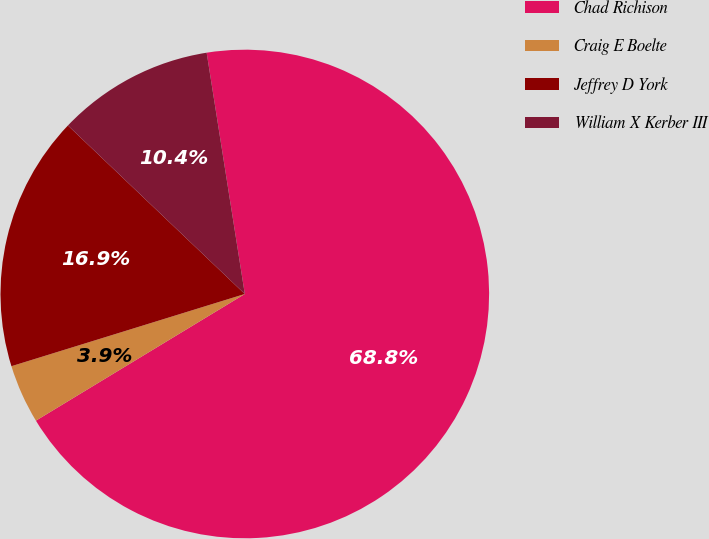<chart> <loc_0><loc_0><loc_500><loc_500><pie_chart><fcel>Chad Richison<fcel>Craig E Boelte<fcel>Jeffrey D York<fcel>William X Kerber III<nl><fcel>68.82%<fcel>3.9%<fcel>16.89%<fcel>10.39%<nl></chart> 